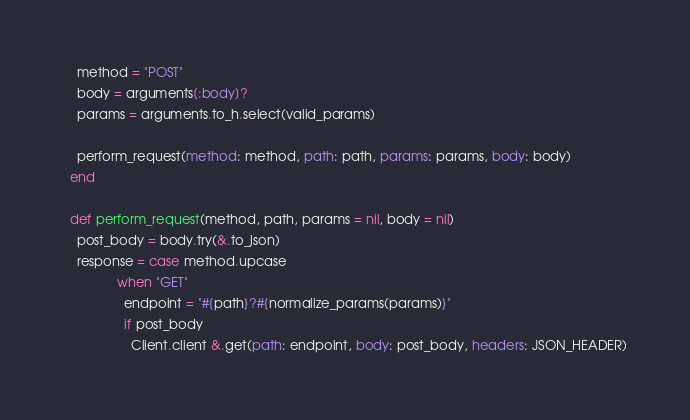<code> <loc_0><loc_0><loc_500><loc_500><_Crystal_>    method = "POST"
    body = arguments[:body]?
    params = arguments.to_h.select(valid_params)

    perform_request(method: method, path: path, params: params, body: body)
  end

  def perform_request(method, path, params = nil, body = nil)
    post_body = body.try(&.to_json)
    response = case method.upcase
               when "GET"
                 endpoint = "#{path}?#{normalize_params(params)}"
                 if post_body
                   Client.client &.get(path: endpoint, body: post_body, headers: JSON_HEADER)</code> 